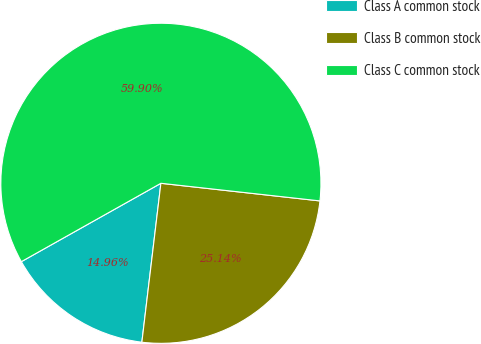Convert chart to OTSL. <chart><loc_0><loc_0><loc_500><loc_500><pie_chart><fcel>Class A common stock<fcel>Class B common stock<fcel>Class C common stock<nl><fcel>14.96%<fcel>25.14%<fcel>59.9%<nl></chart> 